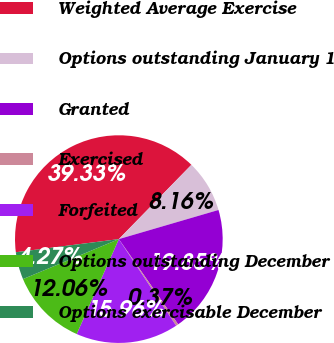Convert chart. <chart><loc_0><loc_0><loc_500><loc_500><pie_chart><fcel>Weighted Average Exercise<fcel>Options outstanding January 1<fcel>Granted<fcel>Exercised<fcel>Forfeited<fcel>Options outstanding December<fcel>Options exercisable December<nl><fcel>39.33%<fcel>8.16%<fcel>19.85%<fcel>0.37%<fcel>15.96%<fcel>12.06%<fcel>4.27%<nl></chart> 